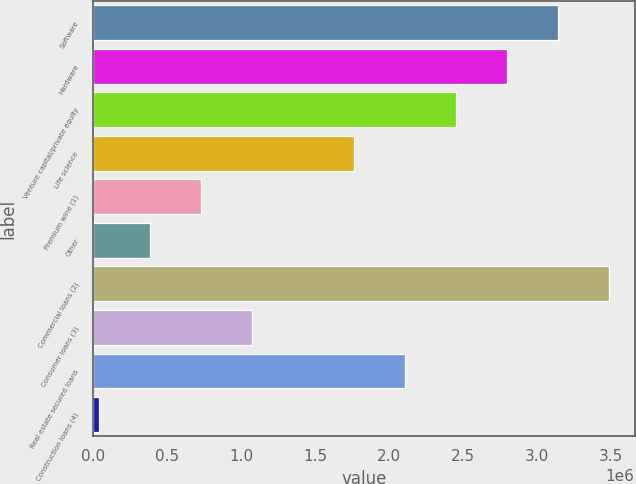<chart> <loc_0><loc_0><loc_500><loc_500><bar_chart><fcel>Software<fcel>Hardware<fcel>Venture capital/private equity<fcel>Life science<fcel>Premium wine (1)<fcel>Other<fcel>Commercial loans (2)<fcel>Consumer loans (3)<fcel>Real estate secured loans<fcel>Construction loans (4)<nl><fcel>3.13791e+06<fcel>2.79341e+06<fcel>2.44892e+06<fcel>1.75993e+06<fcel>726441<fcel>381946<fcel>3.4824e+06<fcel>1.07094e+06<fcel>2.10442e+06<fcel>37451<nl></chart> 